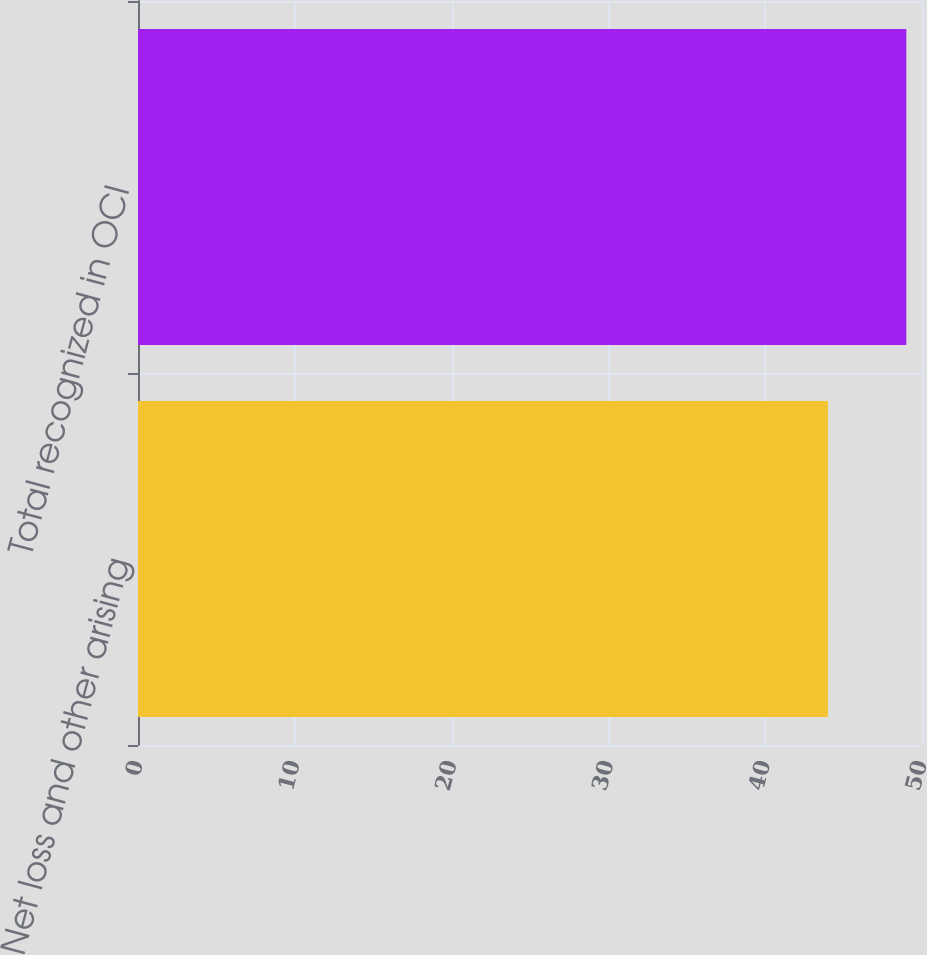Convert chart to OTSL. <chart><loc_0><loc_0><loc_500><loc_500><bar_chart><fcel>Net loss and other arising<fcel>Total recognized in OCI<nl><fcel>44<fcel>49<nl></chart> 